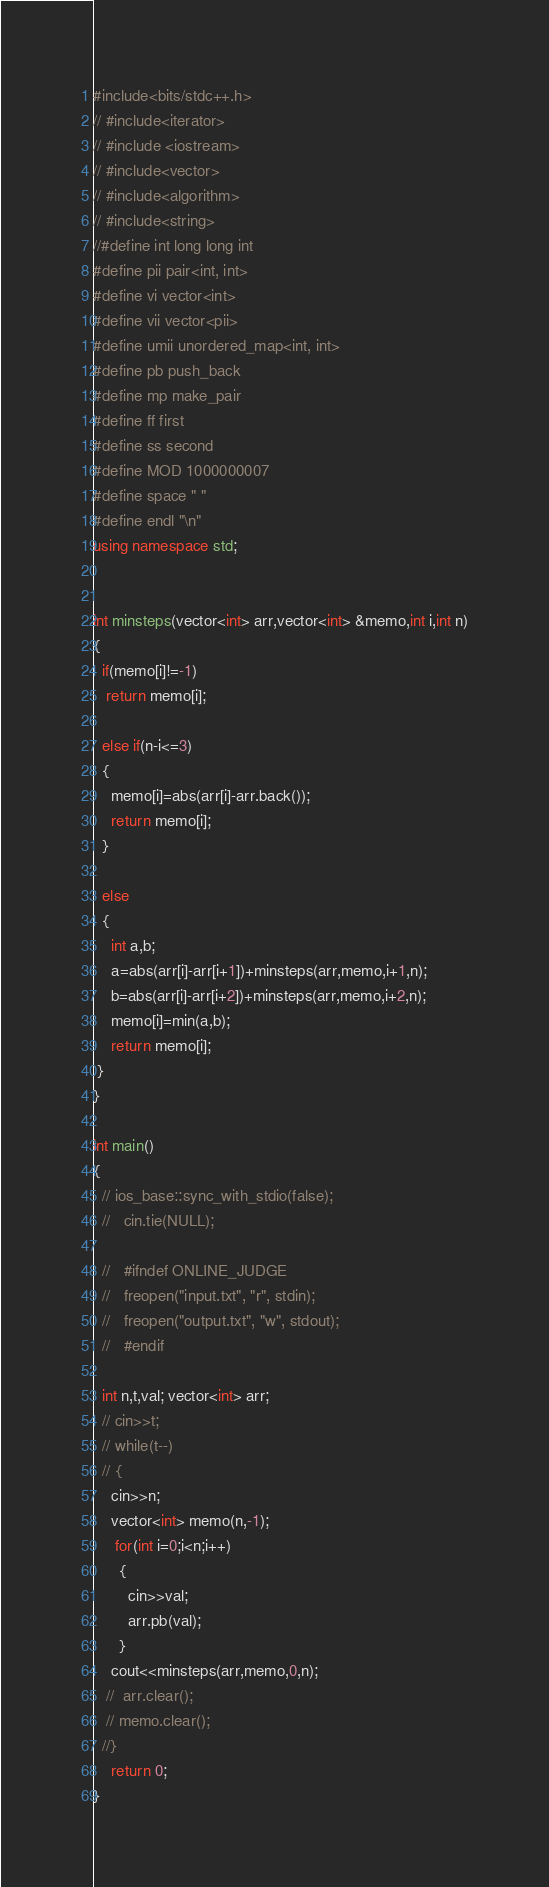Convert code to text. <code><loc_0><loc_0><loc_500><loc_500><_C++_>#include<bits/stdc++.h>
// #include<iterator>
// #include <iostream>
// #include<vector>
// #include<algorithm>
// #include<string>
//#define int long long int
#define pii pair<int, int>
#define vi vector<int>
#define vii vector<pii>
#define umii unordered_map<int, int>
#define pb push_back
#define mp make_pair
#define ff first
#define ss second                                 
#define MOD 1000000007
#define space " "
#define endl "\n"
using namespace std;


int minsteps(vector<int> arr,vector<int> &memo,int i,int n)
{
  if(memo[i]!=-1)
   return memo[i];

  else if(n-i<=3)
  {
  	memo[i]=abs(arr[i]-arr.back());
  	return memo[i];
  }

  else
  {
    int a,b;
    a=abs(arr[i]-arr[i+1])+minsteps(arr,memo,i+1,n);
    b=abs(arr[i]-arr[i+2])+minsteps(arr,memo,i+2,n);
    memo[i]=min(a,b);
    return memo[i];
 }
}

int main()
{
  // ios_base::sync_with_stdio(false);
  //   cin.tie(NULL);
    
  //   #ifndef ONLINE_JUDGE
  //   freopen("input.txt", "r", stdin);
  //   freopen("output.txt", "w", stdout);
  //   #endif
 
  int n,t,val; vector<int> arr;
  // cin>>t;
  // while(t--)
  // {
  	cin>>n;
  	vector<int> memo(n,-1);
     for(int i=0;i<n;i++)
      {
        cin>>val;
        arr.pb(val);
      }    
    cout<<minsteps(arr,memo,0,n);
   //  arr.clear();
   // memo.clear();
  //}
    return 0;
}</code> 